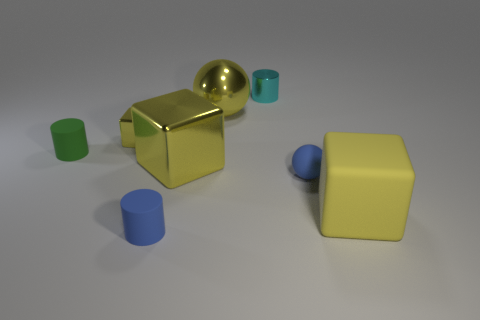Subtract all yellow cubes. How many were subtracted if there are1yellow cubes left? 2 Add 1 small yellow shiny things. How many objects exist? 9 Subtract all big yellow matte cubes. How many cubes are left? 2 Subtract all spheres. How many objects are left? 6 Subtract all blue cylinders. How many cylinders are left? 2 Subtract all brown balls. Subtract all gray cylinders. How many balls are left? 2 Subtract all tiny purple metal blocks. Subtract all small balls. How many objects are left? 7 Add 5 small cyan cylinders. How many small cyan cylinders are left? 6 Add 3 yellow cubes. How many yellow cubes exist? 6 Subtract 0 purple cylinders. How many objects are left? 8 